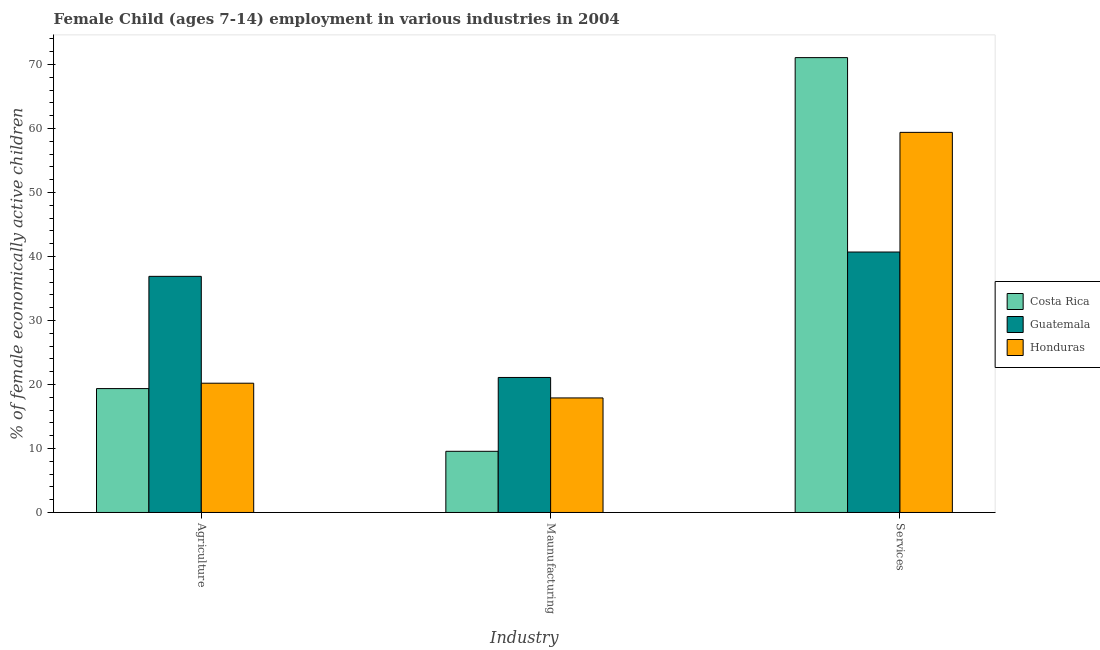How many groups of bars are there?
Give a very brief answer. 3. Are the number of bars per tick equal to the number of legend labels?
Provide a short and direct response. Yes. How many bars are there on the 1st tick from the left?
Keep it short and to the point. 3. What is the label of the 3rd group of bars from the left?
Ensure brevity in your answer.  Services. What is the percentage of economically active children in manufacturing in Honduras?
Provide a short and direct response. 17.9. Across all countries, what is the maximum percentage of economically active children in services?
Your response must be concise. 71.08. Across all countries, what is the minimum percentage of economically active children in services?
Your answer should be very brief. 40.7. In which country was the percentage of economically active children in manufacturing maximum?
Offer a terse response. Guatemala. What is the total percentage of economically active children in services in the graph?
Make the answer very short. 171.18. What is the difference between the percentage of economically active children in manufacturing in Costa Rica and that in Honduras?
Provide a succinct answer. -8.34. What is the difference between the percentage of economically active children in manufacturing in Guatemala and the percentage of economically active children in agriculture in Honduras?
Make the answer very short. 0.9. What is the average percentage of economically active children in services per country?
Provide a short and direct response. 57.06. What is the difference between the percentage of economically active children in manufacturing and percentage of economically active children in services in Guatemala?
Your answer should be very brief. -19.6. In how many countries, is the percentage of economically active children in manufacturing greater than 20 %?
Provide a succinct answer. 1. What is the ratio of the percentage of economically active children in manufacturing in Guatemala to that in Honduras?
Keep it short and to the point. 1.18. Is the percentage of economically active children in manufacturing in Honduras less than that in Costa Rica?
Your response must be concise. No. Is the difference between the percentage of economically active children in agriculture in Guatemala and Honduras greater than the difference between the percentage of economically active children in services in Guatemala and Honduras?
Your answer should be compact. Yes. What is the difference between the highest and the second highest percentage of economically active children in agriculture?
Provide a succinct answer. 16.7. What is the difference between the highest and the lowest percentage of economically active children in services?
Offer a very short reply. 30.38. What does the 3rd bar from the left in Services represents?
Give a very brief answer. Honduras. How many countries are there in the graph?
Your response must be concise. 3. What is the title of the graph?
Your answer should be very brief. Female Child (ages 7-14) employment in various industries in 2004. Does "Madagascar" appear as one of the legend labels in the graph?
Your answer should be very brief. No. What is the label or title of the X-axis?
Provide a short and direct response. Industry. What is the label or title of the Y-axis?
Your answer should be compact. % of female economically active children. What is the % of female economically active children in Costa Rica in Agriculture?
Your answer should be very brief. 19.36. What is the % of female economically active children in Guatemala in Agriculture?
Keep it short and to the point. 36.9. What is the % of female economically active children of Honduras in Agriculture?
Your answer should be very brief. 20.2. What is the % of female economically active children of Costa Rica in Maunufacturing?
Give a very brief answer. 9.56. What is the % of female economically active children in Guatemala in Maunufacturing?
Your answer should be very brief. 21.1. What is the % of female economically active children of Costa Rica in Services?
Keep it short and to the point. 71.08. What is the % of female economically active children of Guatemala in Services?
Your answer should be compact. 40.7. What is the % of female economically active children of Honduras in Services?
Offer a terse response. 59.4. Across all Industry, what is the maximum % of female economically active children in Costa Rica?
Provide a short and direct response. 71.08. Across all Industry, what is the maximum % of female economically active children of Guatemala?
Offer a terse response. 40.7. Across all Industry, what is the maximum % of female economically active children in Honduras?
Provide a succinct answer. 59.4. Across all Industry, what is the minimum % of female economically active children in Costa Rica?
Make the answer very short. 9.56. Across all Industry, what is the minimum % of female economically active children in Guatemala?
Offer a very short reply. 21.1. Across all Industry, what is the minimum % of female economically active children in Honduras?
Ensure brevity in your answer.  17.9. What is the total % of female economically active children in Guatemala in the graph?
Make the answer very short. 98.7. What is the total % of female economically active children of Honduras in the graph?
Keep it short and to the point. 97.5. What is the difference between the % of female economically active children in Costa Rica in Agriculture and that in Services?
Keep it short and to the point. -51.72. What is the difference between the % of female economically active children in Guatemala in Agriculture and that in Services?
Offer a very short reply. -3.8. What is the difference between the % of female economically active children in Honduras in Agriculture and that in Services?
Offer a terse response. -39.2. What is the difference between the % of female economically active children in Costa Rica in Maunufacturing and that in Services?
Ensure brevity in your answer.  -61.52. What is the difference between the % of female economically active children in Guatemala in Maunufacturing and that in Services?
Keep it short and to the point. -19.6. What is the difference between the % of female economically active children of Honduras in Maunufacturing and that in Services?
Provide a short and direct response. -41.5. What is the difference between the % of female economically active children of Costa Rica in Agriculture and the % of female economically active children of Guatemala in Maunufacturing?
Give a very brief answer. -1.74. What is the difference between the % of female economically active children in Costa Rica in Agriculture and the % of female economically active children in Honduras in Maunufacturing?
Offer a very short reply. 1.46. What is the difference between the % of female economically active children of Costa Rica in Agriculture and the % of female economically active children of Guatemala in Services?
Give a very brief answer. -21.34. What is the difference between the % of female economically active children of Costa Rica in Agriculture and the % of female economically active children of Honduras in Services?
Keep it short and to the point. -40.04. What is the difference between the % of female economically active children of Guatemala in Agriculture and the % of female economically active children of Honduras in Services?
Offer a terse response. -22.5. What is the difference between the % of female economically active children in Costa Rica in Maunufacturing and the % of female economically active children in Guatemala in Services?
Your response must be concise. -31.14. What is the difference between the % of female economically active children of Costa Rica in Maunufacturing and the % of female economically active children of Honduras in Services?
Ensure brevity in your answer.  -49.84. What is the difference between the % of female economically active children in Guatemala in Maunufacturing and the % of female economically active children in Honduras in Services?
Keep it short and to the point. -38.3. What is the average % of female economically active children in Costa Rica per Industry?
Offer a very short reply. 33.33. What is the average % of female economically active children in Guatemala per Industry?
Your response must be concise. 32.9. What is the average % of female economically active children of Honduras per Industry?
Provide a succinct answer. 32.5. What is the difference between the % of female economically active children in Costa Rica and % of female economically active children in Guatemala in Agriculture?
Offer a very short reply. -17.54. What is the difference between the % of female economically active children of Costa Rica and % of female economically active children of Honduras in Agriculture?
Provide a short and direct response. -0.84. What is the difference between the % of female economically active children of Costa Rica and % of female economically active children of Guatemala in Maunufacturing?
Your response must be concise. -11.54. What is the difference between the % of female economically active children of Costa Rica and % of female economically active children of Honduras in Maunufacturing?
Offer a very short reply. -8.34. What is the difference between the % of female economically active children in Costa Rica and % of female economically active children in Guatemala in Services?
Offer a terse response. 30.38. What is the difference between the % of female economically active children in Costa Rica and % of female economically active children in Honduras in Services?
Give a very brief answer. 11.68. What is the difference between the % of female economically active children of Guatemala and % of female economically active children of Honduras in Services?
Your answer should be very brief. -18.7. What is the ratio of the % of female economically active children of Costa Rica in Agriculture to that in Maunufacturing?
Offer a terse response. 2.03. What is the ratio of the % of female economically active children of Guatemala in Agriculture to that in Maunufacturing?
Provide a short and direct response. 1.75. What is the ratio of the % of female economically active children of Honduras in Agriculture to that in Maunufacturing?
Provide a succinct answer. 1.13. What is the ratio of the % of female economically active children of Costa Rica in Agriculture to that in Services?
Make the answer very short. 0.27. What is the ratio of the % of female economically active children of Guatemala in Agriculture to that in Services?
Make the answer very short. 0.91. What is the ratio of the % of female economically active children of Honduras in Agriculture to that in Services?
Offer a very short reply. 0.34. What is the ratio of the % of female economically active children of Costa Rica in Maunufacturing to that in Services?
Your answer should be very brief. 0.13. What is the ratio of the % of female economically active children of Guatemala in Maunufacturing to that in Services?
Provide a short and direct response. 0.52. What is the ratio of the % of female economically active children in Honduras in Maunufacturing to that in Services?
Keep it short and to the point. 0.3. What is the difference between the highest and the second highest % of female economically active children in Costa Rica?
Offer a terse response. 51.72. What is the difference between the highest and the second highest % of female economically active children in Honduras?
Provide a succinct answer. 39.2. What is the difference between the highest and the lowest % of female economically active children of Costa Rica?
Your answer should be compact. 61.52. What is the difference between the highest and the lowest % of female economically active children in Guatemala?
Provide a short and direct response. 19.6. What is the difference between the highest and the lowest % of female economically active children in Honduras?
Give a very brief answer. 41.5. 